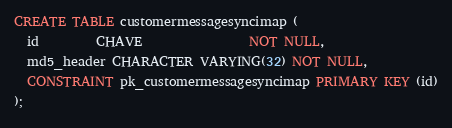Convert code to text. <code><loc_0><loc_0><loc_500><loc_500><_SQL_>CREATE TABLE customermessagesyncimap (
  id         CHAVE                 NOT NULL,
  md5_header CHARACTER VARYING(32) NOT NULL,
  CONSTRAINT pk_customermessagesyncimap PRIMARY KEY (id)
);</code> 